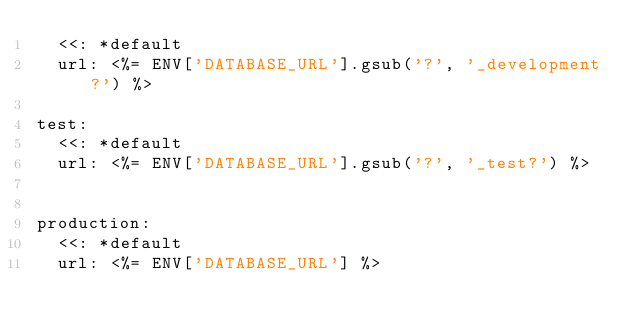Convert code to text. <code><loc_0><loc_0><loc_500><loc_500><_YAML_>  <<: *default
  url: <%= ENV['DATABASE_URL'].gsub('?', '_development?') %>

test:
  <<: *default
  url: <%= ENV['DATABASE_URL'].gsub('?', '_test?') %>


production:
  <<: *default
  url: <%= ENV['DATABASE_URL'] %>
</code> 